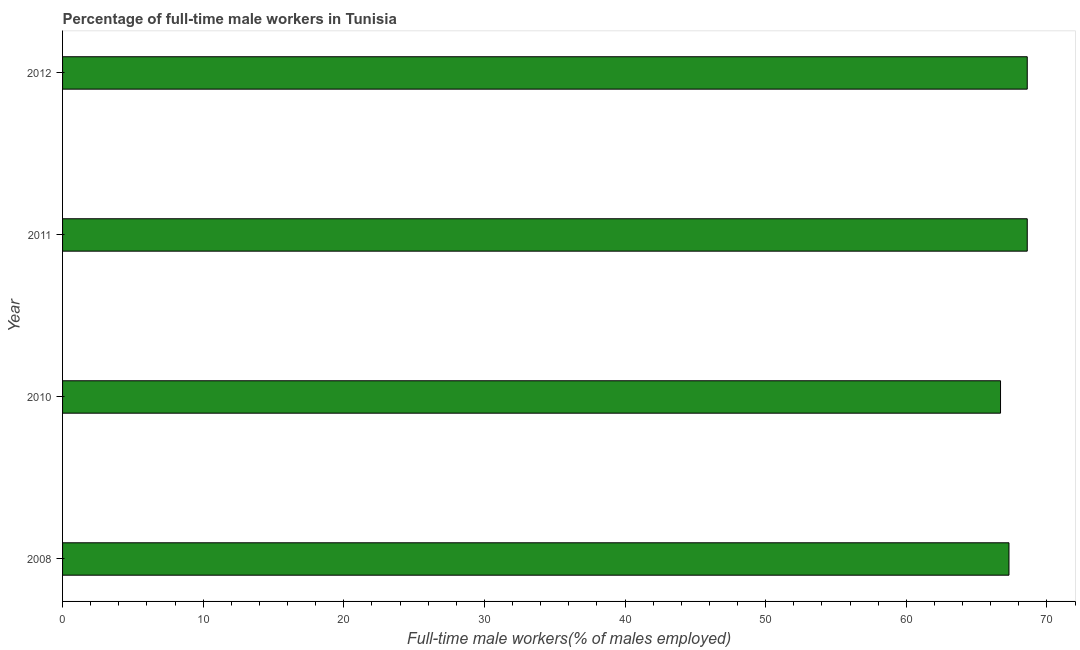Does the graph contain grids?
Provide a short and direct response. No. What is the title of the graph?
Your response must be concise. Percentage of full-time male workers in Tunisia. What is the label or title of the X-axis?
Make the answer very short. Full-time male workers(% of males employed). What is the percentage of full-time male workers in 2008?
Keep it short and to the point. 67.3. Across all years, what is the maximum percentage of full-time male workers?
Provide a short and direct response. 68.6. Across all years, what is the minimum percentage of full-time male workers?
Ensure brevity in your answer.  66.7. In which year was the percentage of full-time male workers maximum?
Provide a succinct answer. 2011. In which year was the percentage of full-time male workers minimum?
Your answer should be very brief. 2010. What is the sum of the percentage of full-time male workers?
Ensure brevity in your answer.  271.2. What is the average percentage of full-time male workers per year?
Make the answer very short. 67.8. What is the median percentage of full-time male workers?
Provide a short and direct response. 67.95. In how many years, is the percentage of full-time male workers greater than 24 %?
Provide a succinct answer. 4. Is the sum of the percentage of full-time male workers in 2008 and 2011 greater than the maximum percentage of full-time male workers across all years?
Provide a short and direct response. Yes. What is the difference between the highest and the lowest percentage of full-time male workers?
Give a very brief answer. 1.9. What is the difference between two consecutive major ticks on the X-axis?
Keep it short and to the point. 10. Are the values on the major ticks of X-axis written in scientific E-notation?
Offer a very short reply. No. What is the Full-time male workers(% of males employed) of 2008?
Your answer should be compact. 67.3. What is the Full-time male workers(% of males employed) in 2010?
Your answer should be very brief. 66.7. What is the Full-time male workers(% of males employed) of 2011?
Offer a very short reply. 68.6. What is the Full-time male workers(% of males employed) of 2012?
Offer a terse response. 68.6. What is the difference between the Full-time male workers(% of males employed) in 2008 and 2010?
Provide a short and direct response. 0.6. What is the ratio of the Full-time male workers(% of males employed) in 2008 to that in 2010?
Offer a terse response. 1.01. What is the ratio of the Full-time male workers(% of males employed) in 2008 to that in 2012?
Keep it short and to the point. 0.98. What is the ratio of the Full-time male workers(% of males employed) in 2010 to that in 2011?
Your response must be concise. 0.97. What is the ratio of the Full-time male workers(% of males employed) in 2011 to that in 2012?
Your answer should be compact. 1. 